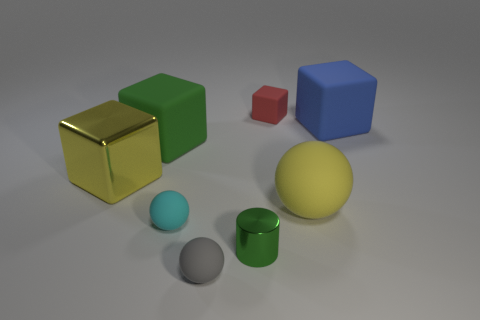Subtract 1 spheres. How many spheres are left? 2 Subtract all yellow cubes. How many cubes are left? 3 Subtract all tiny cubes. How many cubes are left? 3 Add 1 metal blocks. How many objects exist? 9 Subtract all gray blocks. Subtract all cyan spheres. How many blocks are left? 4 Subtract all cylinders. How many objects are left? 7 Subtract all small matte objects. Subtract all large yellow blocks. How many objects are left? 4 Add 7 shiny objects. How many shiny objects are left? 9 Add 5 small shiny cylinders. How many small shiny cylinders exist? 6 Subtract 0 red spheres. How many objects are left? 8 